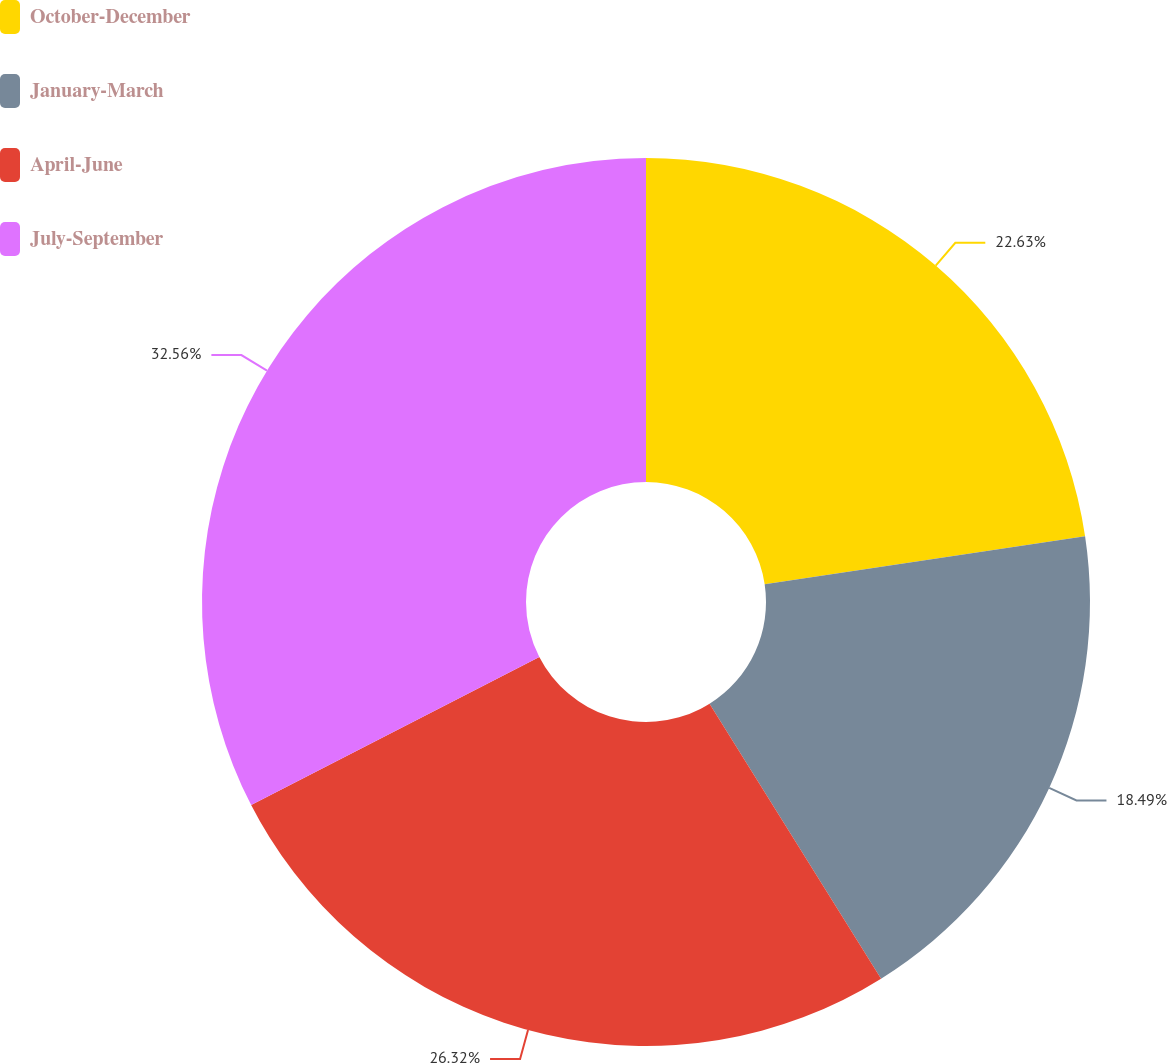Convert chart to OTSL. <chart><loc_0><loc_0><loc_500><loc_500><pie_chart><fcel>October-December<fcel>January-March<fcel>April-June<fcel>July-September<nl><fcel>22.63%<fcel>18.49%<fcel>26.32%<fcel>32.56%<nl></chart> 